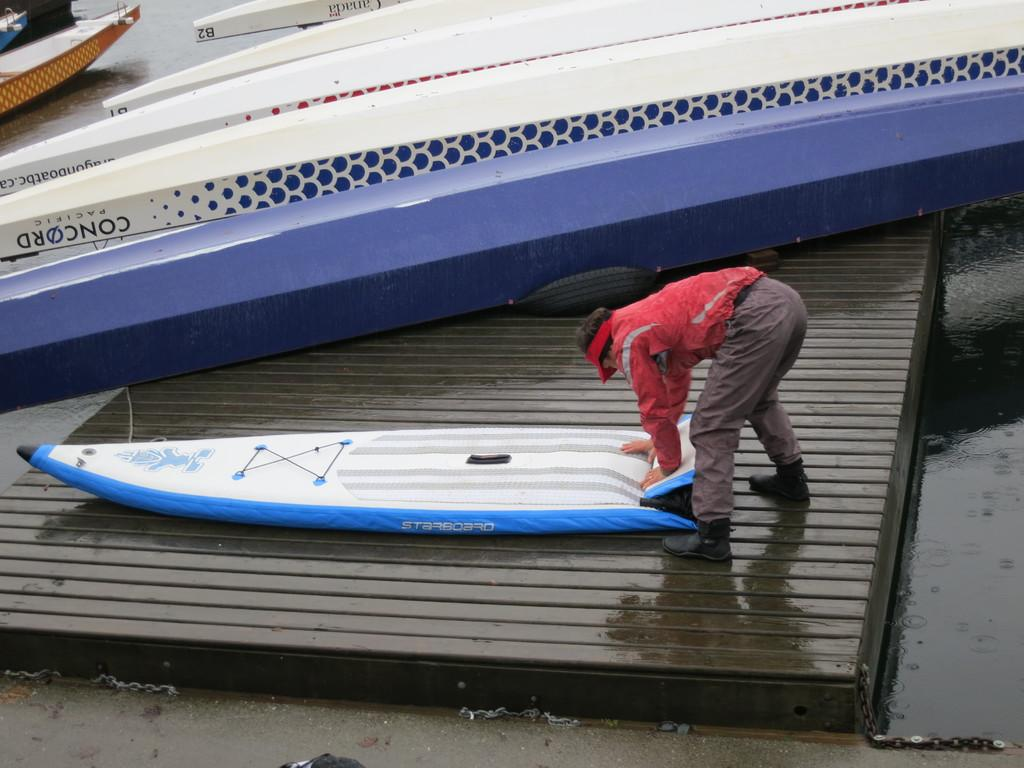What can be seen in large numbers in the image? There are fleets of boats in the image. What object is placed near the road in the image? A tire is kept on the roadside in the image. What natural element is visible in the image? There is water visible in the image. What is the person in the image doing? The person is holding an object in the image. What time of day is the image taken? The image appears to be taken during the day. What type of chess piece is the person holding in the image? There is no chess piece present in the image; the person is holding an unspecified object. What year is the image taken in? The image does not provide any information about the year it was taken. Can you tell me which zoo the person is visiting in the image? There is no indication of a zoo or any animals in the image. 